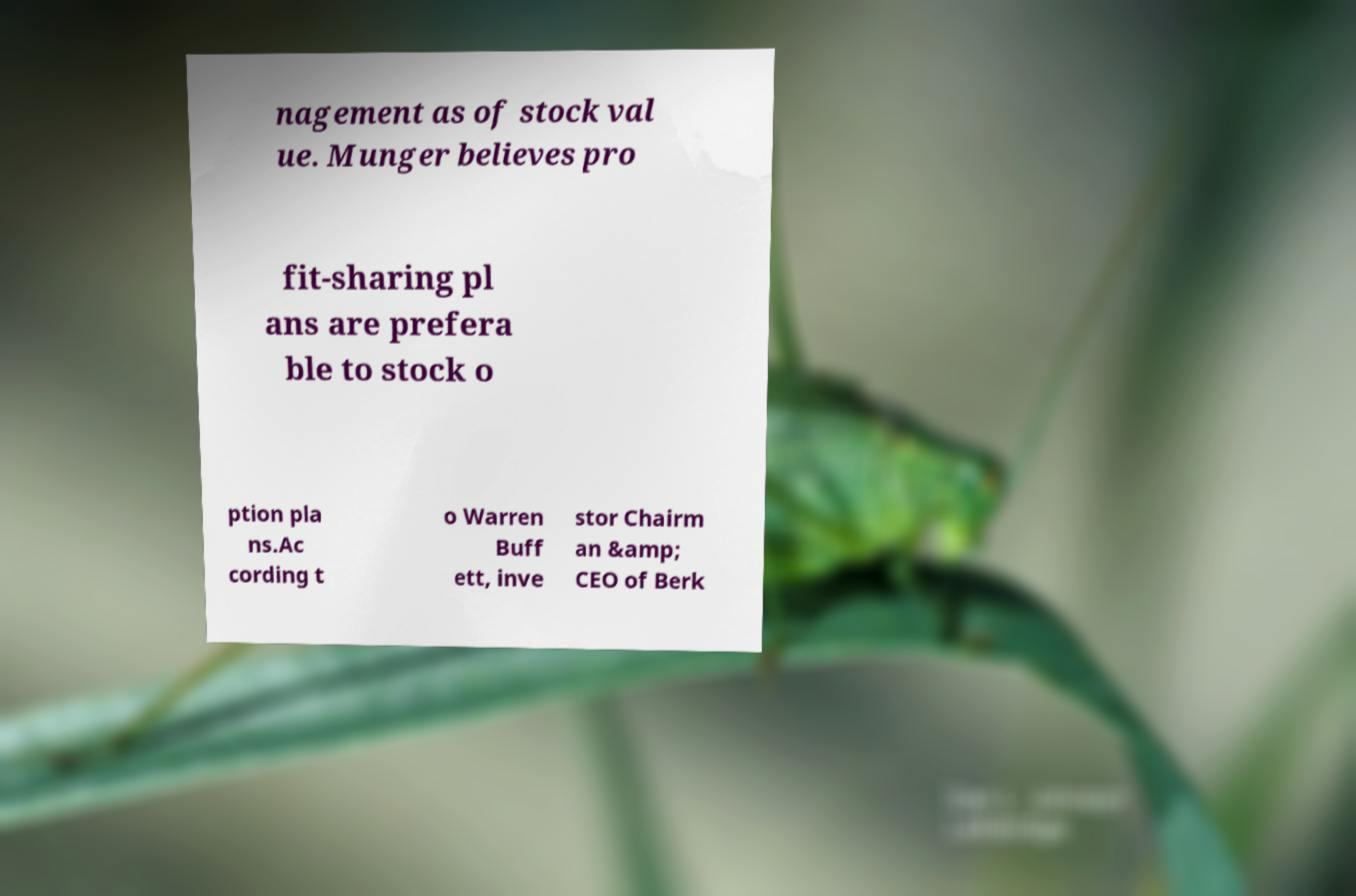Could you assist in decoding the text presented in this image and type it out clearly? nagement as of stock val ue. Munger believes pro fit-sharing pl ans are prefera ble to stock o ption pla ns.Ac cording t o Warren Buff ett, inve stor Chairm an &amp; CEO of Berk 